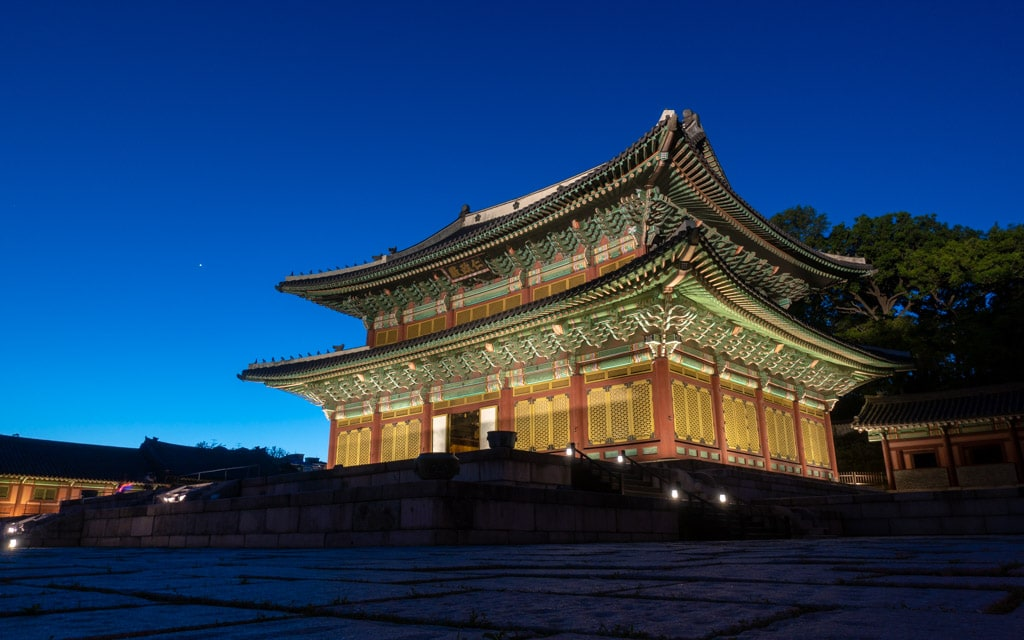What can you tell me about the historical significance of Changdeokgung Palace? Changdeokgung Palace, built in the 15th century, is one of the 'Five Grand Palaces' built by the kings of the Joseon Dynasty. It is renowned for its architectural ingenuity that is well-adapted to its natural surroundings, earning it a UNESCO World Heritage Site designation. Unlike other palaces, Changdeokgung was the most favored by royals due to its location and layout, perfecting the art of architectural harmony with nature. Its historical significance also lies in its endurance through various periods of turmoil, serving as a royal residence longer than any other royal palace in Korea. 